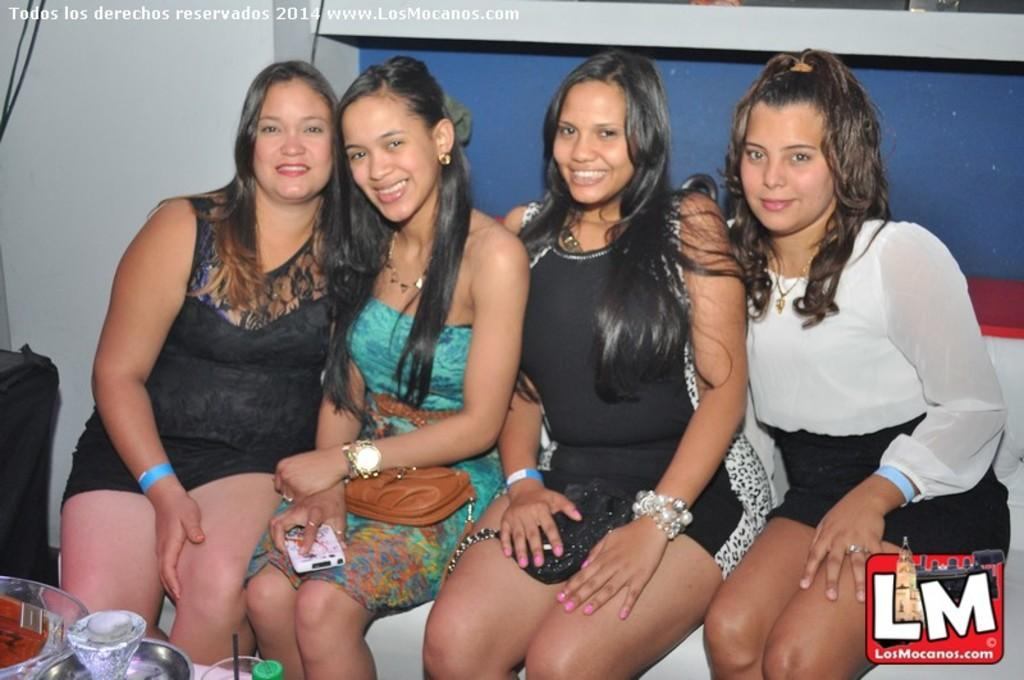How many individuals are present in the image? There are four people in the image. Can you describe any objects that are visible on a table in the image? Unfortunately, the provided facts do not mention any specific objects on the table. What type of riddle is being solved by the people in the image? There is no indication in the image that the people are solving a riddle. What kind of pet can be seen accompanying the people in the image? There is no pet present in the image. 